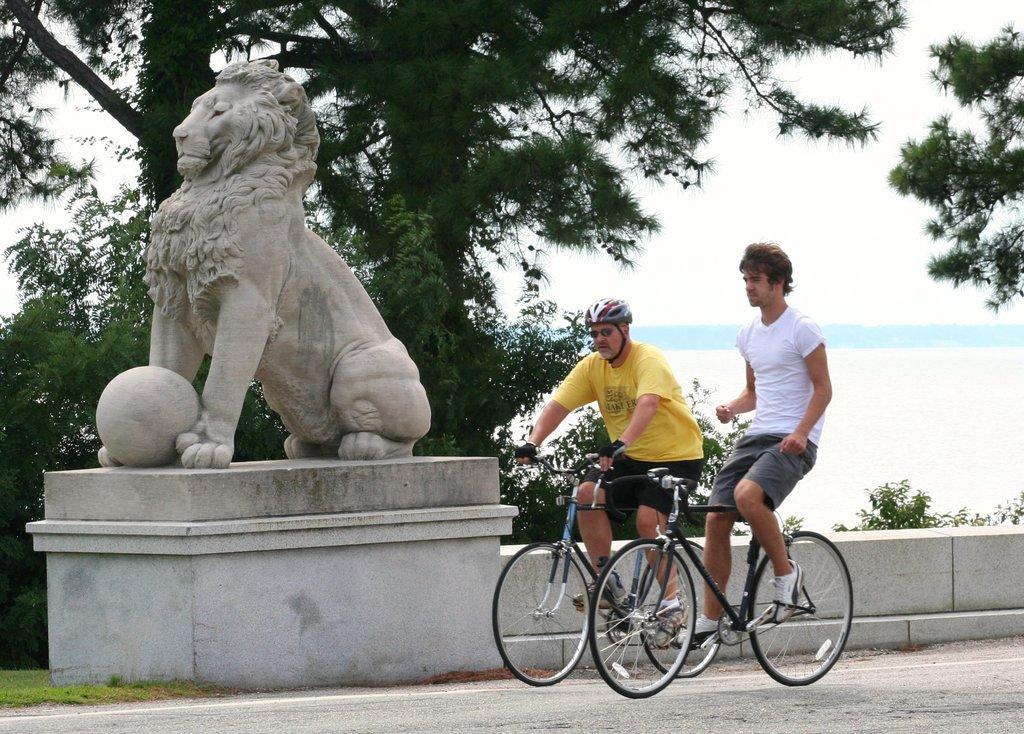In one or two sentences, can you explain what this image depicts? there is a Lions sculpture with the ball beside that there are two men riding the bicycle. 